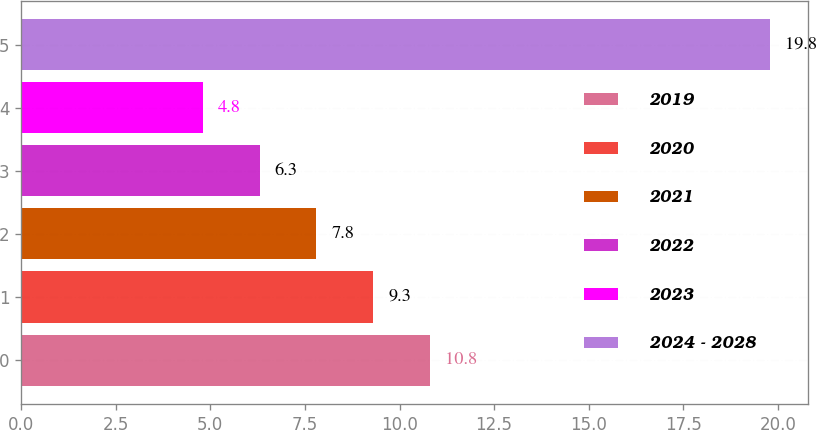Convert chart. <chart><loc_0><loc_0><loc_500><loc_500><bar_chart><fcel>2019<fcel>2020<fcel>2021<fcel>2022<fcel>2023<fcel>2024 - 2028<nl><fcel>10.8<fcel>9.3<fcel>7.8<fcel>6.3<fcel>4.8<fcel>19.8<nl></chart> 